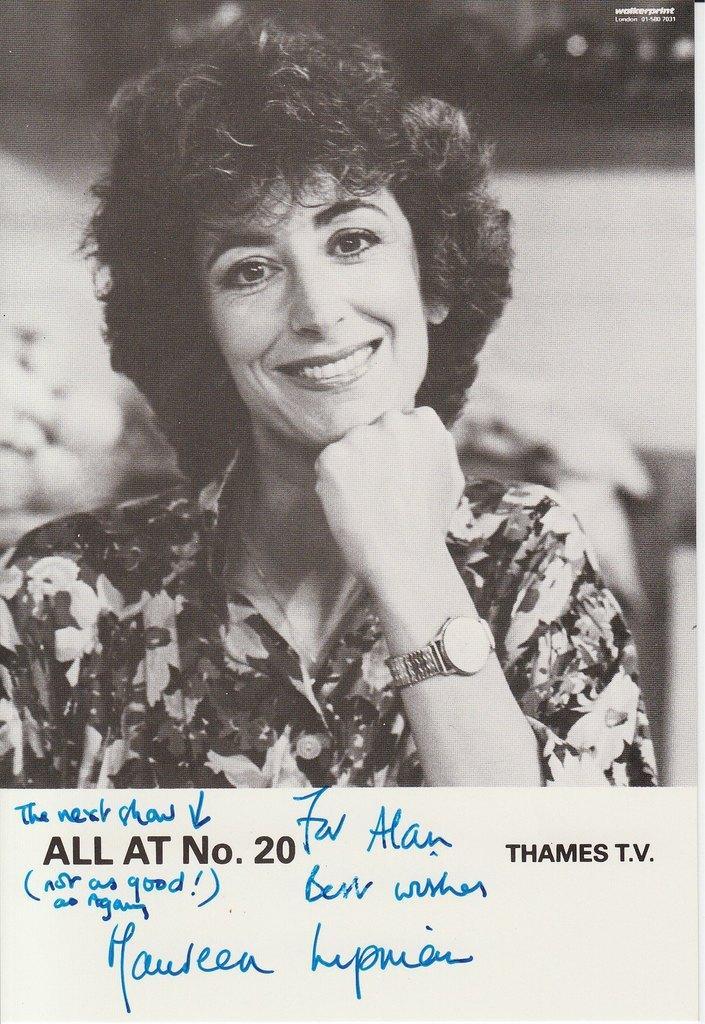In one or two sentences, can you explain what this image depicts? Here I can see a black and white photograph of a woman. She is smiling and giving pose for the picture. There is a watch to her left hand. The background is blurred. At the bottom of this photograph there is some text. 